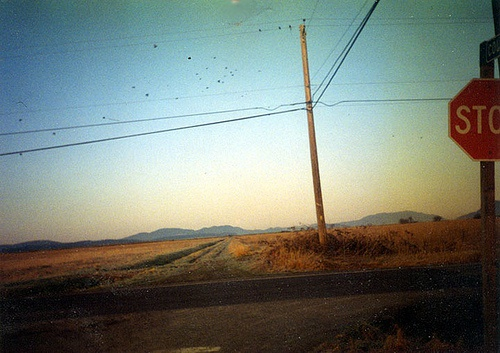Describe the objects in this image and their specific colors. I can see stop sign in blue, maroon, and brown tones, bird in blue, lightblue, gray, and darkgray tones, bird in blue, lightblue, and gray tones, bird in blue, teal, and lightblue tones, and bird in blue, gray, and teal tones in this image. 